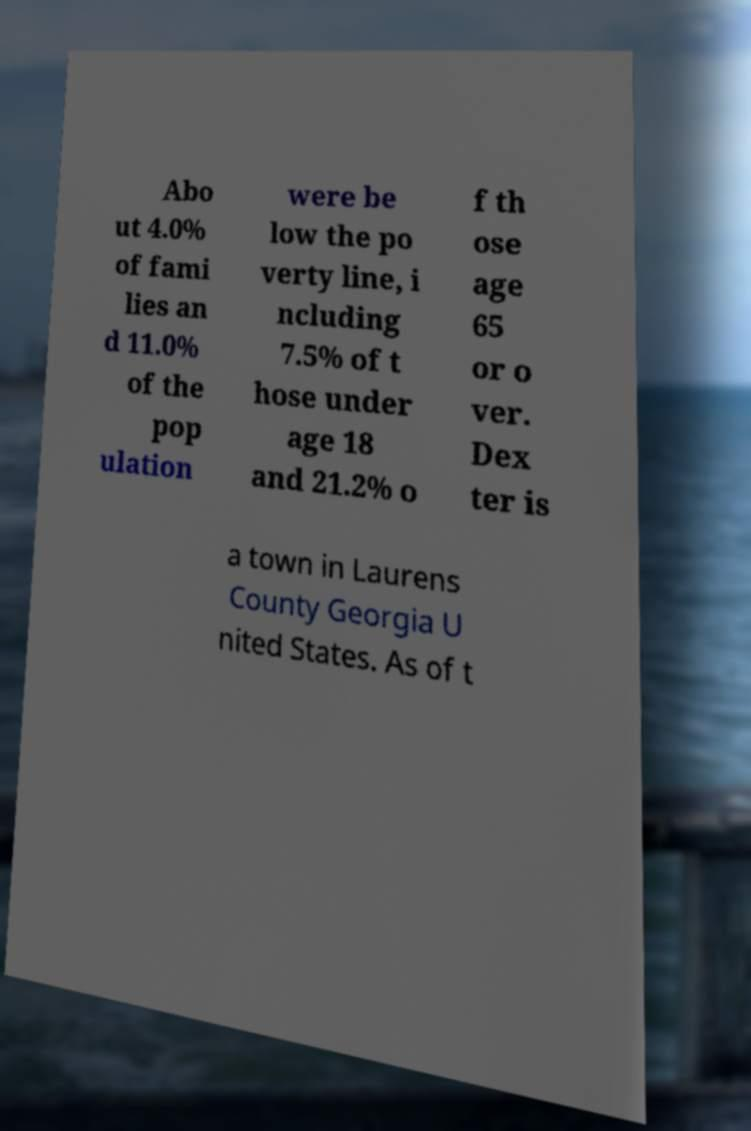Could you extract and type out the text from this image? Abo ut 4.0% of fami lies an d 11.0% of the pop ulation were be low the po verty line, i ncluding 7.5% of t hose under age 18 and 21.2% o f th ose age 65 or o ver. Dex ter is a town in Laurens County Georgia U nited States. As of t 